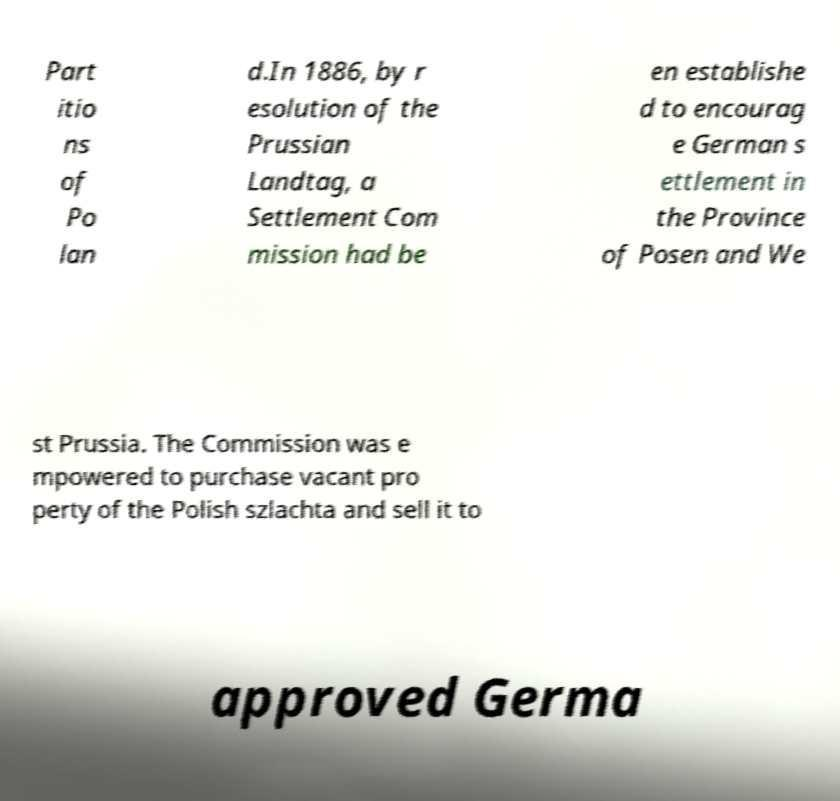Please identify and transcribe the text found in this image. Part itio ns of Po lan d.In 1886, by r esolution of the Prussian Landtag, a Settlement Com mission had be en establishe d to encourag e German s ettlement in the Province of Posen and We st Prussia. The Commission was e mpowered to purchase vacant pro perty of the Polish szlachta and sell it to approved Germa 